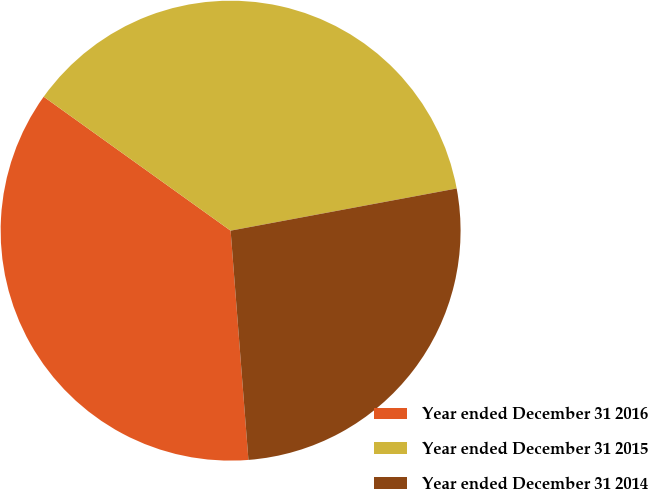Convert chart. <chart><loc_0><loc_0><loc_500><loc_500><pie_chart><fcel>Year ended December 31 2016<fcel>Year ended December 31 2015<fcel>Year ended December 31 2014<nl><fcel>36.13%<fcel>37.17%<fcel>26.7%<nl></chart> 